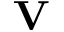Convert formula to latex. <formula><loc_0><loc_0><loc_500><loc_500>V</formula> 